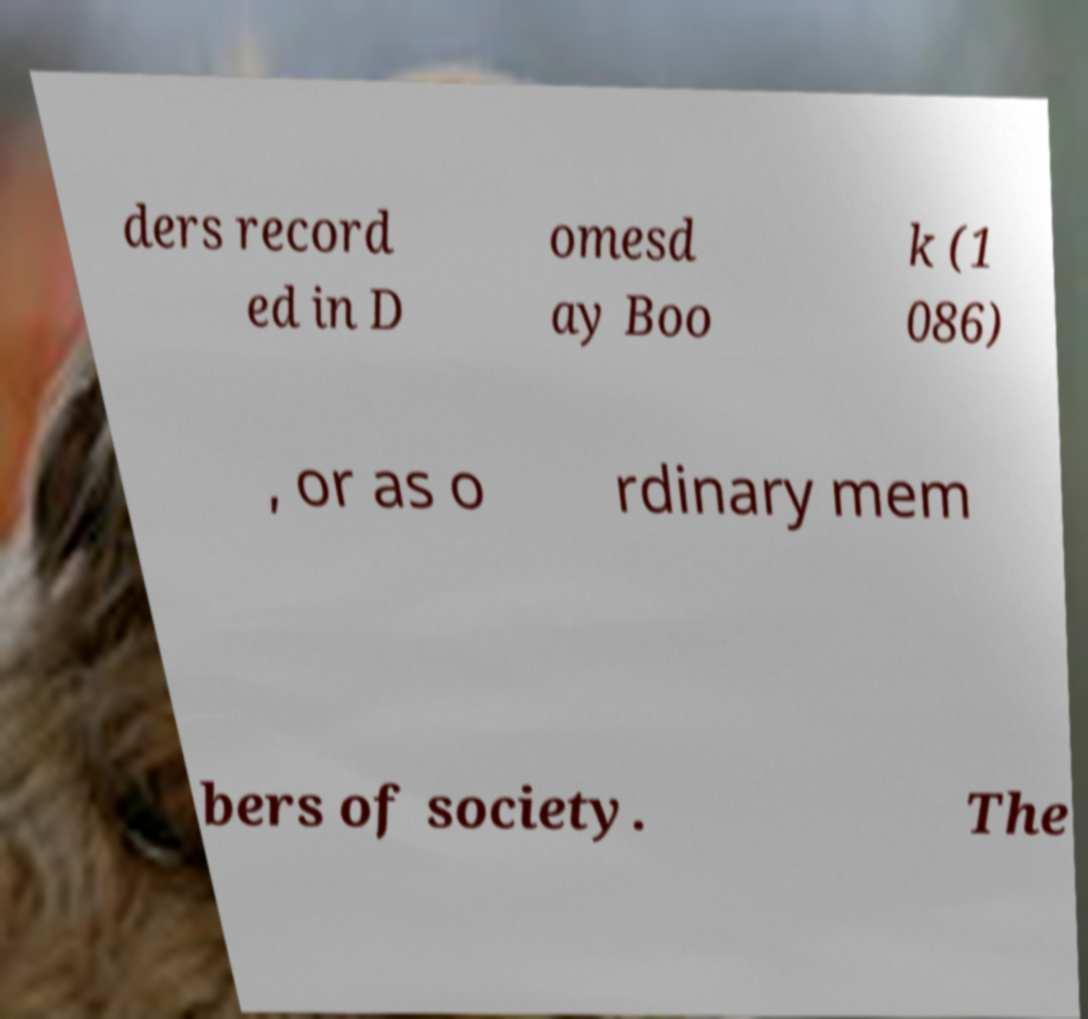What messages or text are displayed in this image? I need them in a readable, typed format. ders record ed in D omesd ay Boo k (1 086) , or as o rdinary mem bers of society. The 